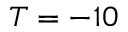Convert formula to latex. <formula><loc_0><loc_0><loc_500><loc_500>T = - 1 0</formula> 